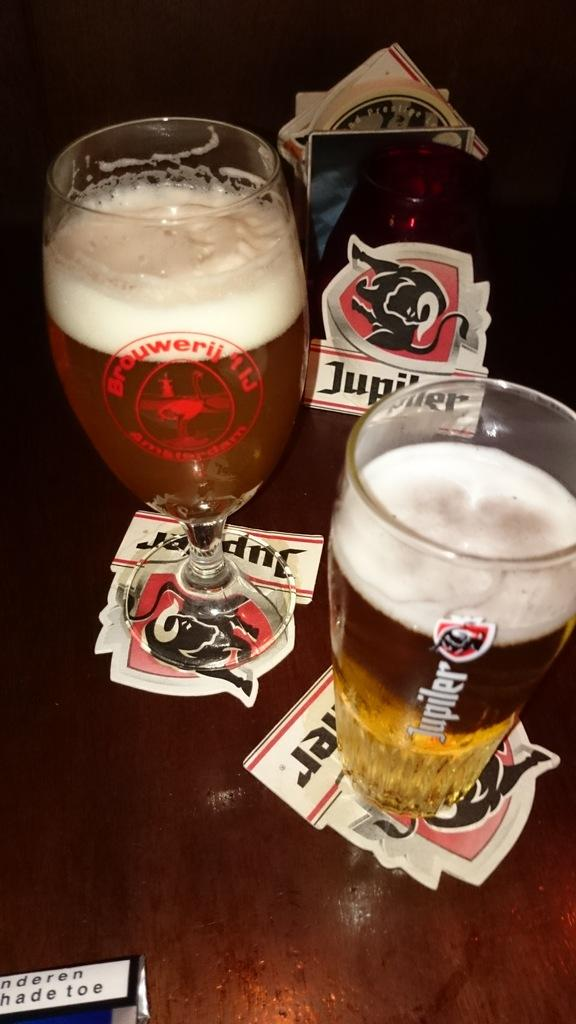Provide a one-sentence caption for the provided image. Two beer glasses and coasters with one from Jupiler. 